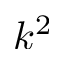Convert formula to latex. <formula><loc_0><loc_0><loc_500><loc_500>k ^ { 2 }</formula> 